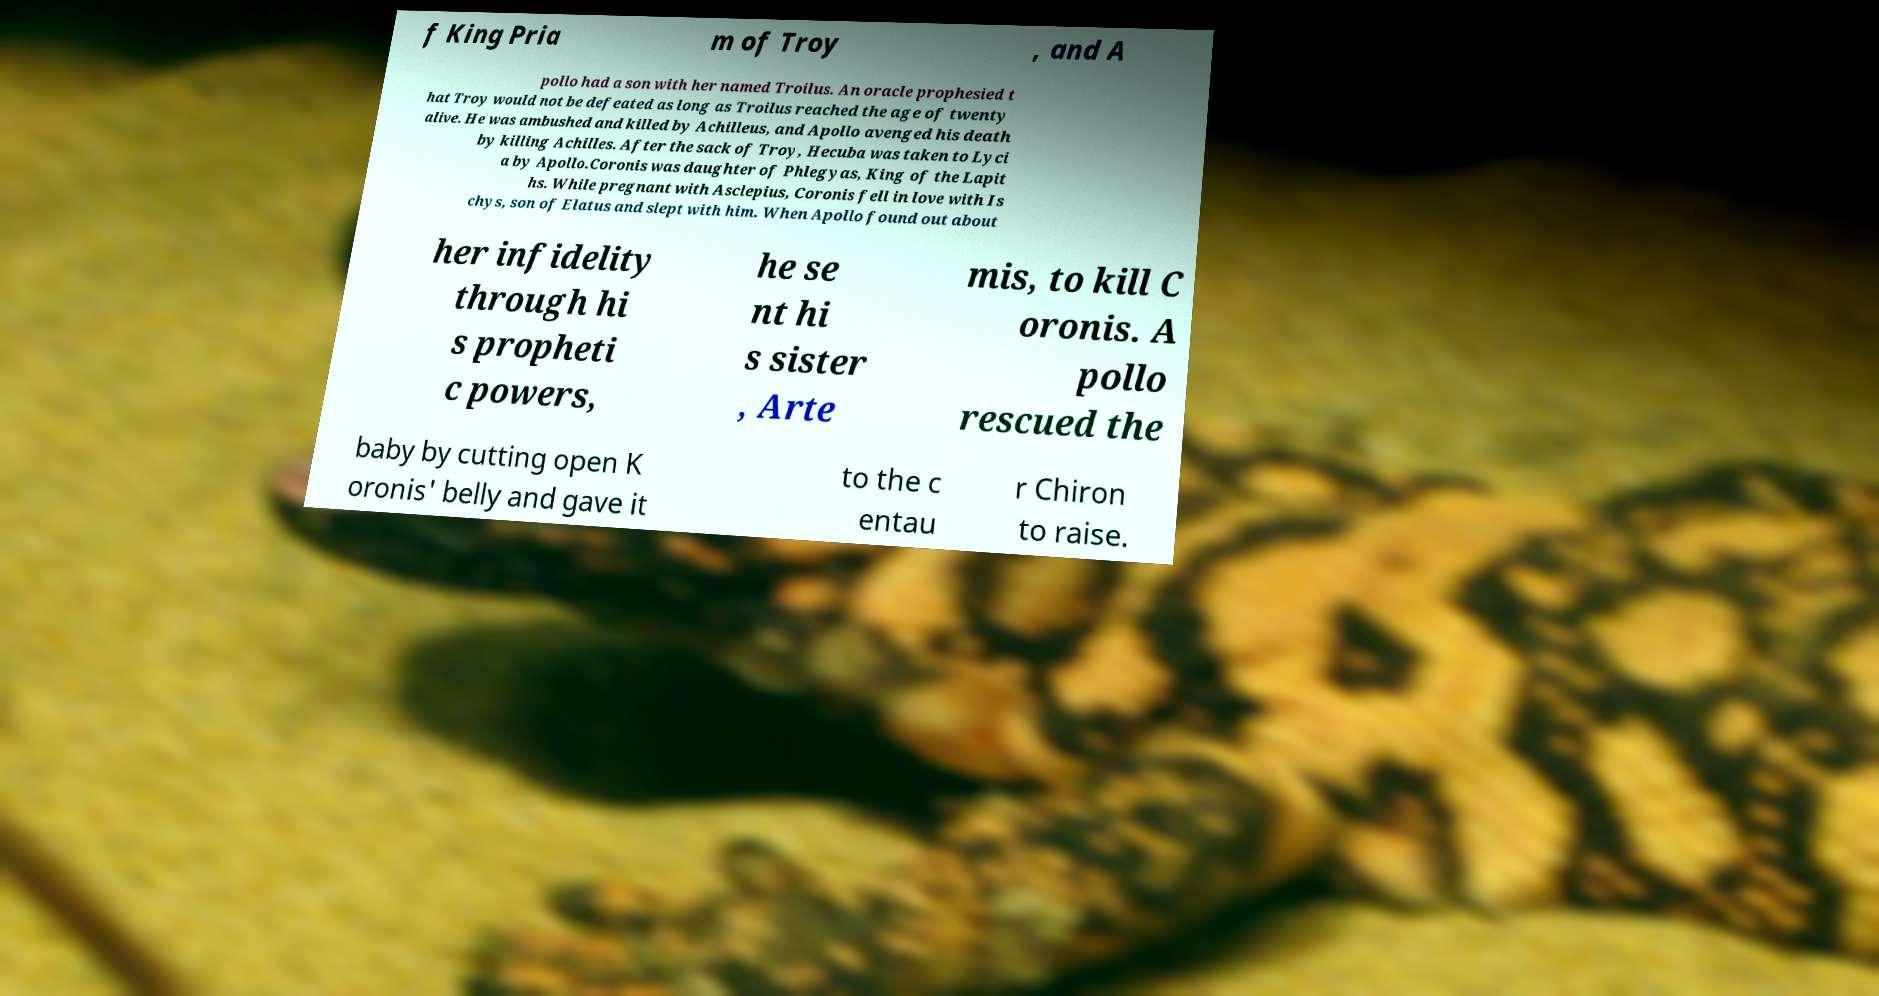Could you assist in decoding the text presented in this image and type it out clearly? f King Pria m of Troy , and A pollo had a son with her named Troilus. An oracle prophesied t hat Troy would not be defeated as long as Troilus reached the age of twenty alive. He was ambushed and killed by Achilleus, and Apollo avenged his death by killing Achilles. After the sack of Troy, Hecuba was taken to Lyci a by Apollo.Coronis was daughter of Phlegyas, King of the Lapit hs. While pregnant with Asclepius, Coronis fell in love with Is chys, son of Elatus and slept with him. When Apollo found out about her infidelity through hi s propheti c powers, he se nt hi s sister , Arte mis, to kill C oronis. A pollo rescued the baby by cutting open K oronis' belly and gave it to the c entau r Chiron to raise. 